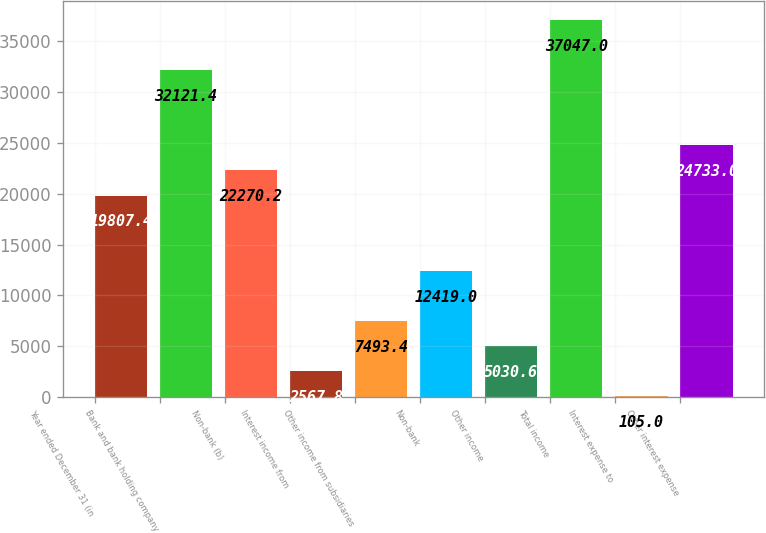Convert chart. <chart><loc_0><loc_0><loc_500><loc_500><bar_chart><fcel>Year ended December 31 (in<fcel>Bank and bank holding company<fcel>Non-bank (b)<fcel>Interest income from<fcel>Other income from subsidiaries<fcel>Non-bank<fcel>Other income<fcel>Total income<fcel>Interest expense to<fcel>Other interest expense<nl><fcel>19807.4<fcel>32121.4<fcel>22270.2<fcel>2567.8<fcel>7493.4<fcel>12419<fcel>5030.6<fcel>37047<fcel>105<fcel>24733<nl></chart> 